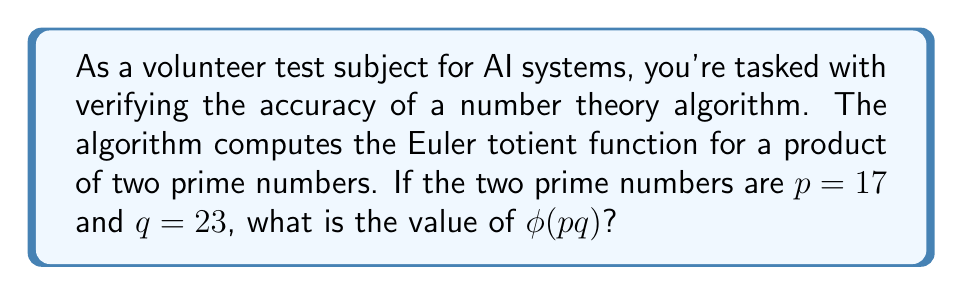Help me with this question. Let's approach this step-by-step:

1) The Euler totient function $\phi(n)$ counts the number of integers up to $n$ that are coprime to $n$.

2) For a prime number $p$, $\phi(p) = p - 1$, because all positive integers less than $p$ are coprime to it.

3) For a product of two distinct primes $p$ and $q$, the Euler totient function is given by:

   $$\phi(pq) = \phi(p) \cdot \phi(q)$$

   This is due to the multiplicative property of the Euler totient function.

4) In our case, $p = 17$ and $q = 23$. So we need to calculate:

   $$\phi(17 \cdot 23) = \phi(17) \cdot \phi(23)$$

5) We know that for prime numbers:
   
   $$\phi(17) = 17 - 1 = 16$$
   $$\phi(23) = 23 - 1 = 22$$

6) Therefore:

   $$\phi(17 \cdot 23) = 16 \cdot 22 = 352$$

Thus, the value of $\phi(pq)$ for $p = 17$ and $q = 23$ is 352.
Answer: $\phi(17 \cdot 23) = 352$ 